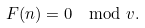<formula> <loc_0><loc_0><loc_500><loc_500>F ( n ) = 0 \mod v .</formula> 